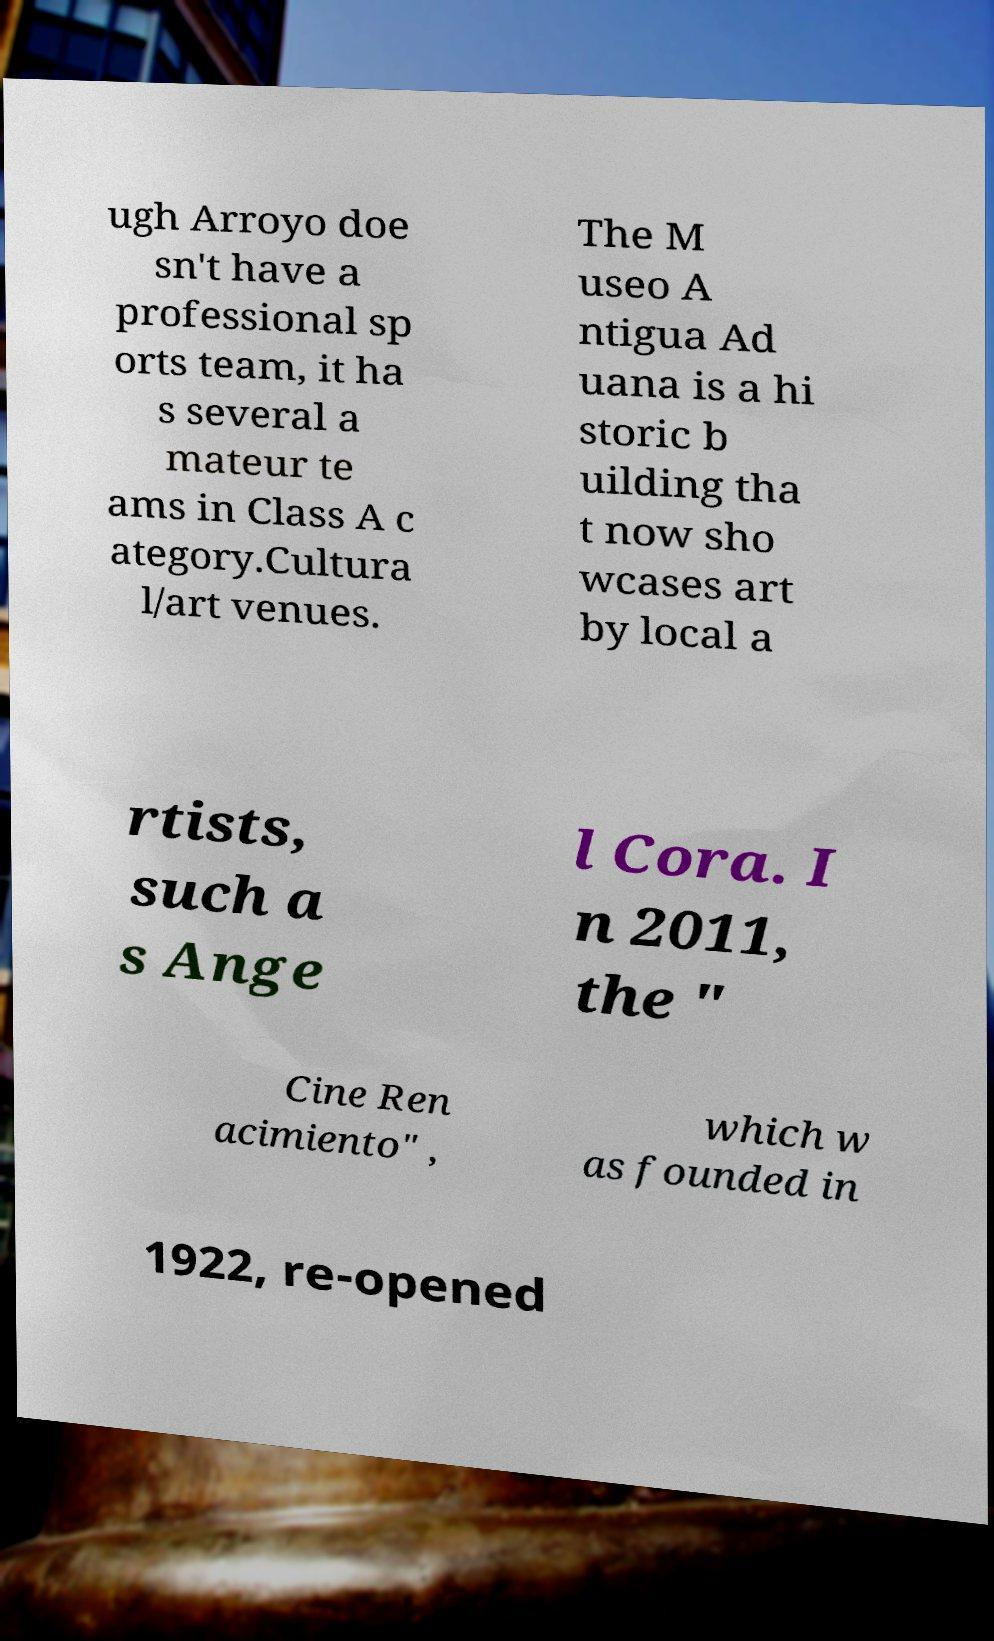Could you extract and type out the text from this image? ugh Arroyo doe sn't have a professional sp orts team, it ha s several a mateur te ams in Class A c ategory.Cultura l/art venues. The M useo A ntigua Ad uana is a hi storic b uilding tha t now sho wcases art by local a rtists, such a s Ange l Cora. I n 2011, the " Cine Ren acimiento" , which w as founded in 1922, re-opened 